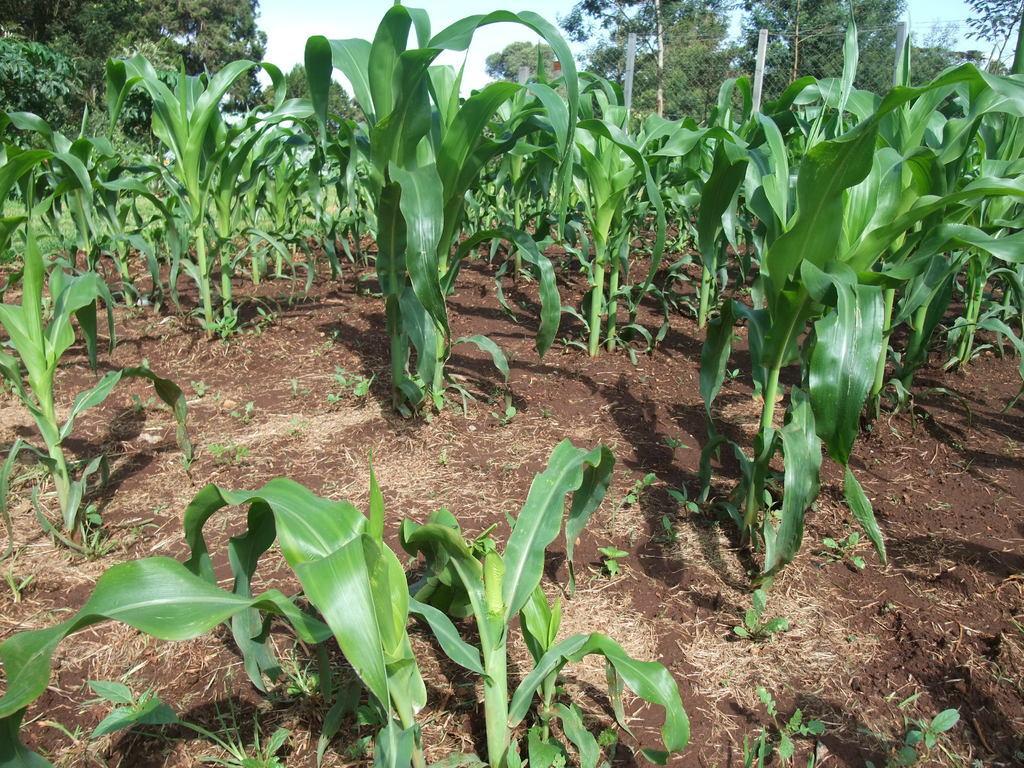Can you describe this image briefly? In the background of the image we can see the plants and ground. At the top of the image we can see the trees, mesh and sky. 